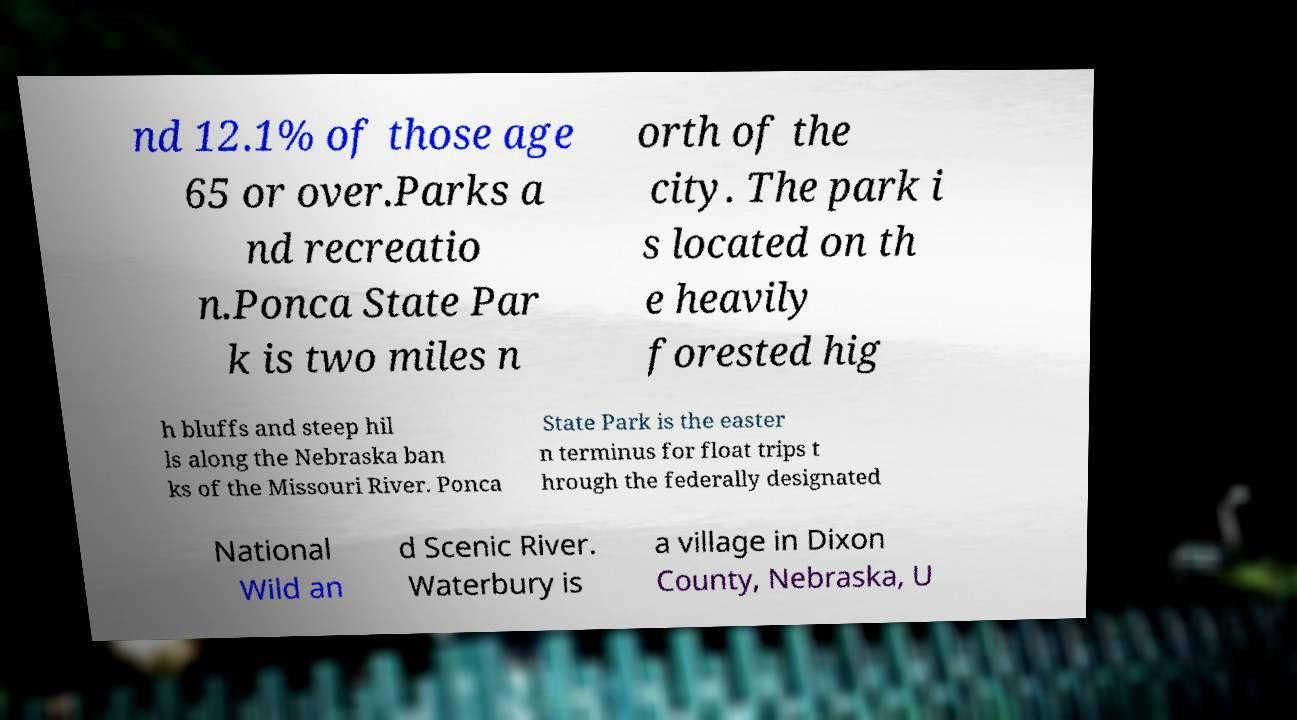For documentation purposes, I need the text within this image transcribed. Could you provide that? nd 12.1% of those age 65 or over.Parks a nd recreatio n.Ponca State Par k is two miles n orth of the city. The park i s located on th e heavily forested hig h bluffs and steep hil ls along the Nebraska ban ks of the Missouri River. Ponca State Park is the easter n terminus for float trips t hrough the federally designated National Wild an d Scenic River. Waterbury is a village in Dixon County, Nebraska, U 